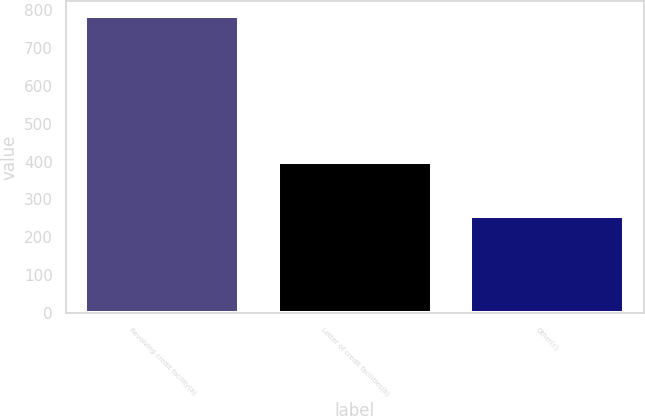Convert chart to OTSL. <chart><loc_0><loc_0><loc_500><loc_500><bar_chart><fcel>Revolving credit facility(a)<fcel>Letter of credit facilities(b)<fcel>Other(c)<nl><fcel>785<fcel>400<fcel>257<nl></chart> 